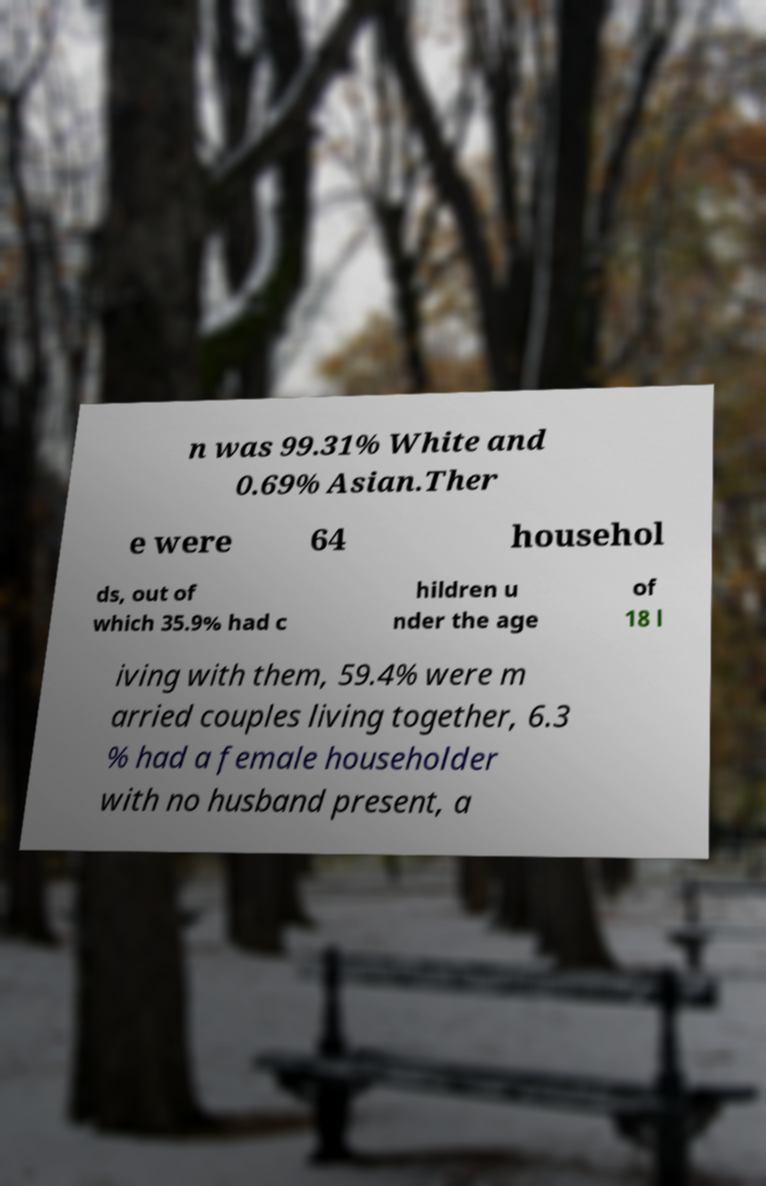Could you assist in decoding the text presented in this image and type it out clearly? n was 99.31% White and 0.69% Asian.Ther e were 64 househol ds, out of which 35.9% had c hildren u nder the age of 18 l iving with them, 59.4% were m arried couples living together, 6.3 % had a female householder with no husband present, a 